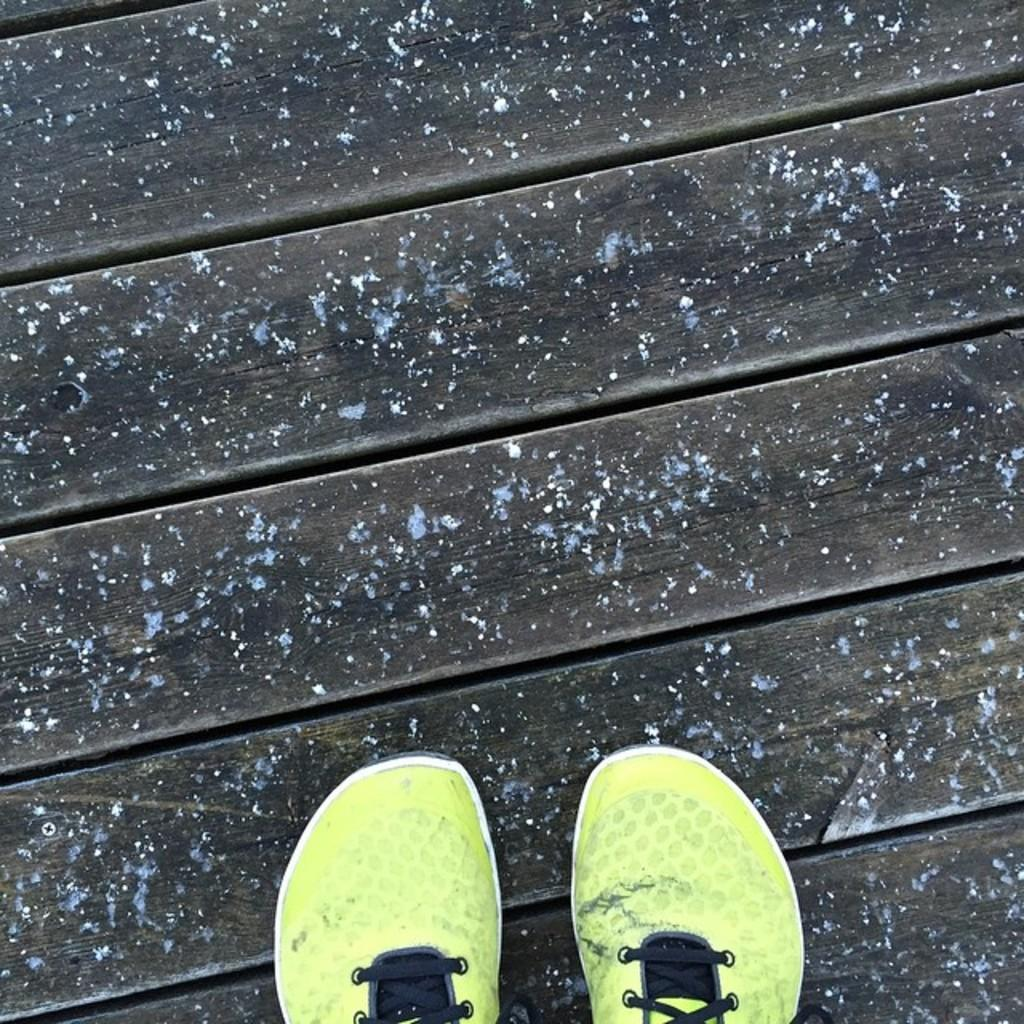What objects are present in the image? There are shoes in the image. What is the shoes resting on? The shoes are on a wooden surface. What colors can be seen on the shoes? The shoes are black and yellow in color. Can you see the moon in the image? No, the moon is not present in the image; it features shoes on a wooden surface. 